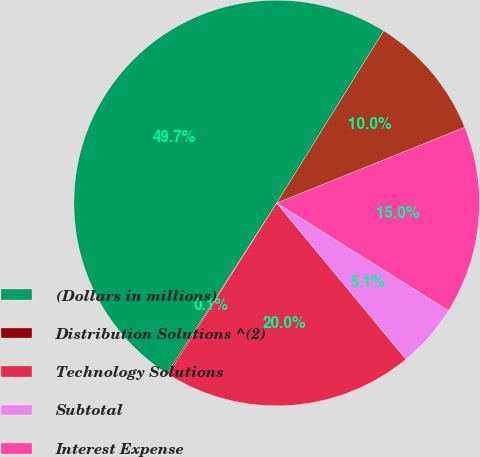<chart> <loc_0><loc_0><loc_500><loc_500><pie_chart><fcel>(Dollars in millions)<fcel>Distribution Solutions ^(2)<fcel>Technology Solutions<fcel>Subtotal<fcel>Interest Expense<fcel>Income from Continuing<nl><fcel>49.75%<fcel>0.12%<fcel>19.98%<fcel>5.09%<fcel>15.01%<fcel>10.05%<nl></chart> 